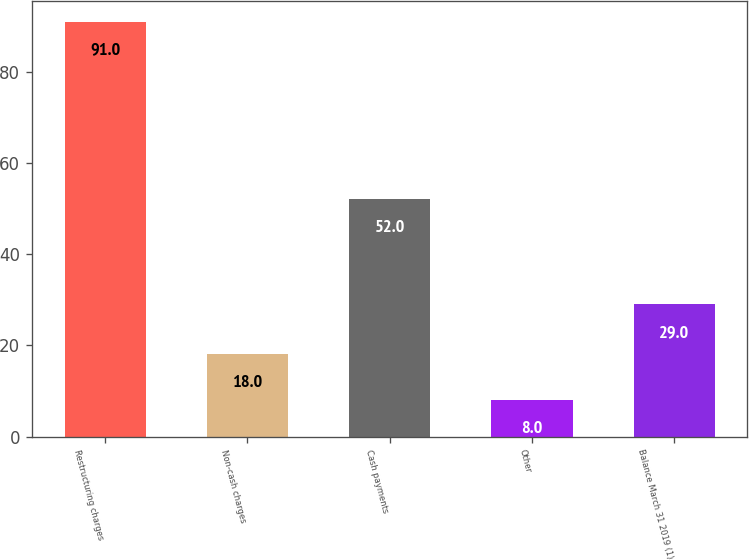Convert chart to OTSL. <chart><loc_0><loc_0><loc_500><loc_500><bar_chart><fcel>Restructuring charges<fcel>Non-cash charges<fcel>Cash payments<fcel>Other<fcel>Balance March 31 2019 (1)<nl><fcel>91<fcel>18<fcel>52<fcel>8<fcel>29<nl></chart> 